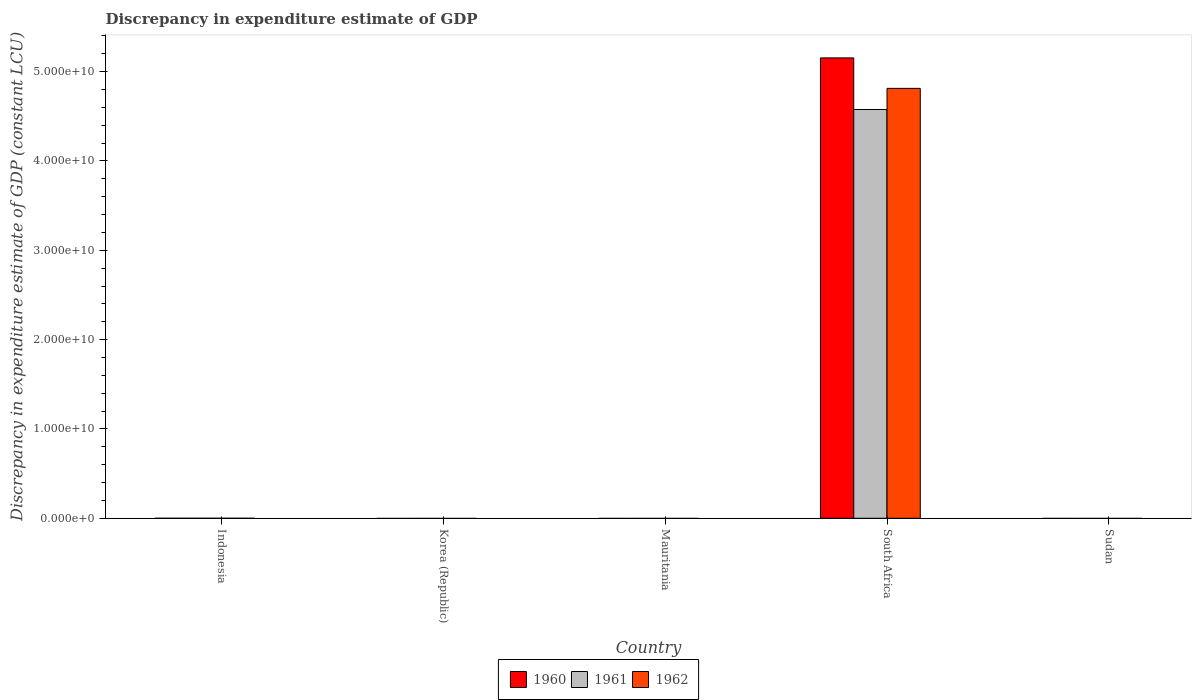How many different coloured bars are there?
Offer a terse response. 3. Are the number of bars per tick equal to the number of legend labels?
Give a very brief answer. No. Are the number of bars on each tick of the X-axis equal?
Your answer should be very brief. No. How many bars are there on the 5th tick from the left?
Ensure brevity in your answer.  0. What is the label of the 5th group of bars from the left?
Keep it short and to the point. Sudan. What is the discrepancy in expenditure estimate of GDP in 1961 in South Africa?
Make the answer very short. 4.58e+1. Across all countries, what is the maximum discrepancy in expenditure estimate of GDP in 1960?
Provide a succinct answer. 5.15e+1. Across all countries, what is the minimum discrepancy in expenditure estimate of GDP in 1961?
Make the answer very short. 0. In which country was the discrepancy in expenditure estimate of GDP in 1961 maximum?
Ensure brevity in your answer.  South Africa. What is the total discrepancy in expenditure estimate of GDP in 1960 in the graph?
Make the answer very short. 5.15e+1. What is the average discrepancy in expenditure estimate of GDP in 1960 per country?
Provide a short and direct response. 1.03e+1. What is the difference between the discrepancy in expenditure estimate of GDP of/in 1962 and discrepancy in expenditure estimate of GDP of/in 1961 in South Africa?
Offer a very short reply. 2.37e+09. What is the difference between the highest and the lowest discrepancy in expenditure estimate of GDP in 1962?
Your response must be concise. 4.81e+1. In how many countries, is the discrepancy in expenditure estimate of GDP in 1961 greater than the average discrepancy in expenditure estimate of GDP in 1961 taken over all countries?
Offer a very short reply. 1. Is it the case that in every country, the sum of the discrepancy in expenditure estimate of GDP in 1960 and discrepancy in expenditure estimate of GDP in 1962 is greater than the discrepancy in expenditure estimate of GDP in 1961?
Your answer should be very brief. No. How many bars are there?
Your answer should be very brief. 3. Are all the bars in the graph horizontal?
Offer a very short reply. No. How many countries are there in the graph?
Offer a terse response. 5. What is the difference between two consecutive major ticks on the Y-axis?
Offer a terse response. 1.00e+1. Are the values on the major ticks of Y-axis written in scientific E-notation?
Ensure brevity in your answer.  Yes. Does the graph contain any zero values?
Ensure brevity in your answer.  Yes. Where does the legend appear in the graph?
Provide a short and direct response. Bottom center. How many legend labels are there?
Ensure brevity in your answer.  3. How are the legend labels stacked?
Offer a terse response. Horizontal. What is the title of the graph?
Keep it short and to the point. Discrepancy in expenditure estimate of GDP. Does "1980" appear as one of the legend labels in the graph?
Provide a short and direct response. No. What is the label or title of the X-axis?
Provide a succinct answer. Country. What is the label or title of the Y-axis?
Your response must be concise. Discrepancy in expenditure estimate of GDP (constant LCU). What is the Discrepancy in expenditure estimate of GDP (constant LCU) of 1962 in Korea (Republic)?
Provide a short and direct response. 0. What is the Discrepancy in expenditure estimate of GDP (constant LCU) in 1962 in Mauritania?
Your response must be concise. 0. What is the Discrepancy in expenditure estimate of GDP (constant LCU) of 1960 in South Africa?
Keep it short and to the point. 5.15e+1. What is the Discrepancy in expenditure estimate of GDP (constant LCU) of 1961 in South Africa?
Your answer should be very brief. 4.58e+1. What is the Discrepancy in expenditure estimate of GDP (constant LCU) of 1962 in South Africa?
Your response must be concise. 4.81e+1. What is the Discrepancy in expenditure estimate of GDP (constant LCU) in 1961 in Sudan?
Give a very brief answer. 0. Across all countries, what is the maximum Discrepancy in expenditure estimate of GDP (constant LCU) of 1960?
Give a very brief answer. 5.15e+1. Across all countries, what is the maximum Discrepancy in expenditure estimate of GDP (constant LCU) in 1961?
Keep it short and to the point. 4.58e+1. Across all countries, what is the maximum Discrepancy in expenditure estimate of GDP (constant LCU) of 1962?
Keep it short and to the point. 4.81e+1. Across all countries, what is the minimum Discrepancy in expenditure estimate of GDP (constant LCU) of 1960?
Make the answer very short. 0. Across all countries, what is the minimum Discrepancy in expenditure estimate of GDP (constant LCU) of 1961?
Your response must be concise. 0. What is the total Discrepancy in expenditure estimate of GDP (constant LCU) in 1960 in the graph?
Offer a very short reply. 5.15e+1. What is the total Discrepancy in expenditure estimate of GDP (constant LCU) of 1961 in the graph?
Provide a succinct answer. 4.58e+1. What is the total Discrepancy in expenditure estimate of GDP (constant LCU) of 1962 in the graph?
Ensure brevity in your answer.  4.81e+1. What is the average Discrepancy in expenditure estimate of GDP (constant LCU) of 1960 per country?
Keep it short and to the point. 1.03e+1. What is the average Discrepancy in expenditure estimate of GDP (constant LCU) of 1961 per country?
Your response must be concise. 9.15e+09. What is the average Discrepancy in expenditure estimate of GDP (constant LCU) of 1962 per country?
Make the answer very short. 9.62e+09. What is the difference between the Discrepancy in expenditure estimate of GDP (constant LCU) of 1960 and Discrepancy in expenditure estimate of GDP (constant LCU) of 1961 in South Africa?
Provide a short and direct response. 5.78e+09. What is the difference between the Discrepancy in expenditure estimate of GDP (constant LCU) in 1960 and Discrepancy in expenditure estimate of GDP (constant LCU) in 1962 in South Africa?
Offer a terse response. 3.41e+09. What is the difference between the Discrepancy in expenditure estimate of GDP (constant LCU) of 1961 and Discrepancy in expenditure estimate of GDP (constant LCU) of 1962 in South Africa?
Offer a terse response. -2.37e+09. What is the difference between the highest and the lowest Discrepancy in expenditure estimate of GDP (constant LCU) of 1960?
Provide a short and direct response. 5.15e+1. What is the difference between the highest and the lowest Discrepancy in expenditure estimate of GDP (constant LCU) of 1961?
Offer a very short reply. 4.58e+1. What is the difference between the highest and the lowest Discrepancy in expenditure estimate of GDP (constant LCU) of 1962?
Make the answer very short. 4.81e+1. 